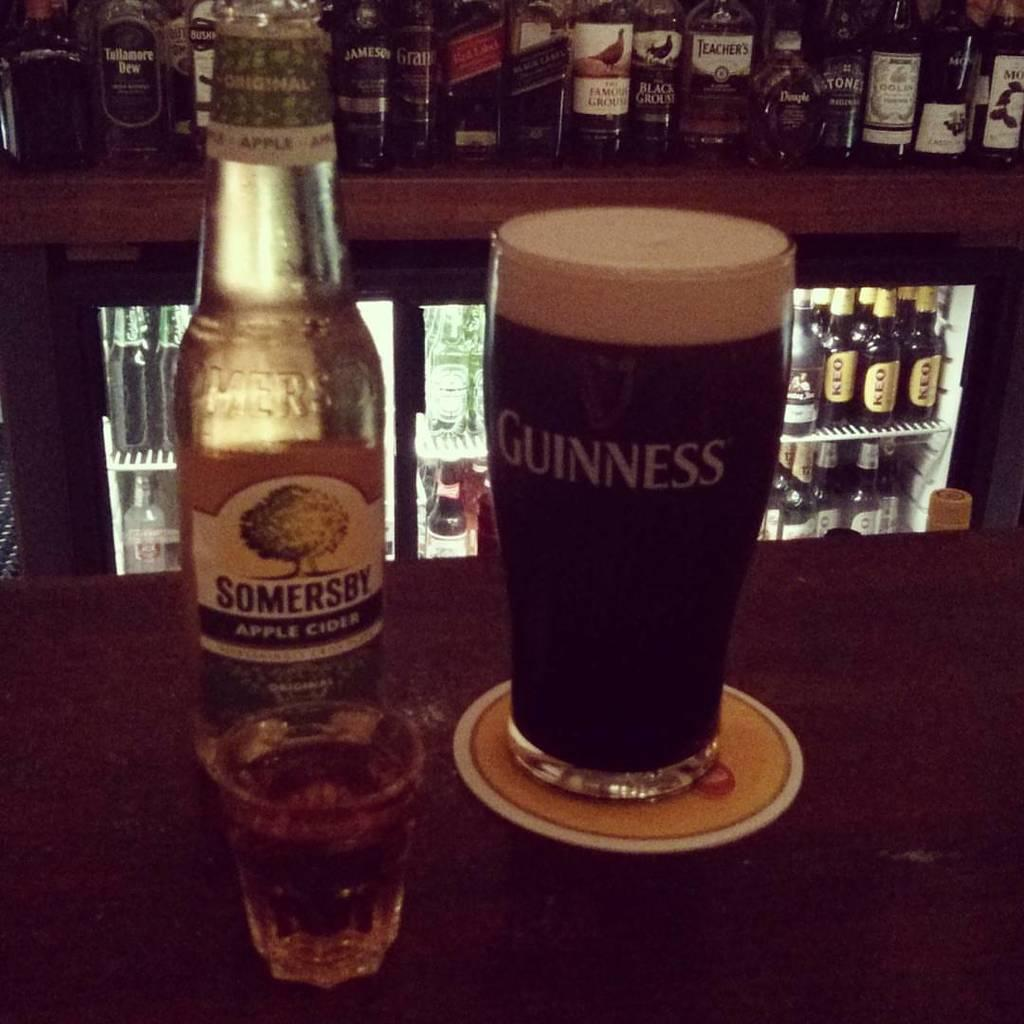<image>
Relay a brief, clear account of the picture shown. A bottle of Somersby has been poured in a Guinness glass 